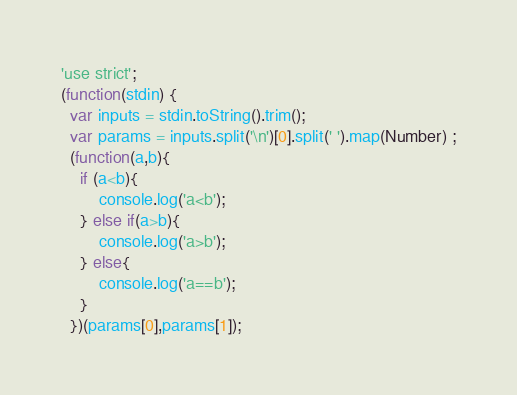<code> <loc_0><loc_0><loc_500><loc_500><_JavaScript_>'use strict';
(function(stdin) { 
  var inputs = stdin.toString().trim();
  var params = inputs.split('\n')[0].split(' ').map(Number) ;
  (function(a,b){
    if (a<b){
        console.log('a<b');
    } else if(a>b){
        console.log('a>b');
    } else{
        console.log('a==b');
    }
  })(params[0],params[1]);</code> 